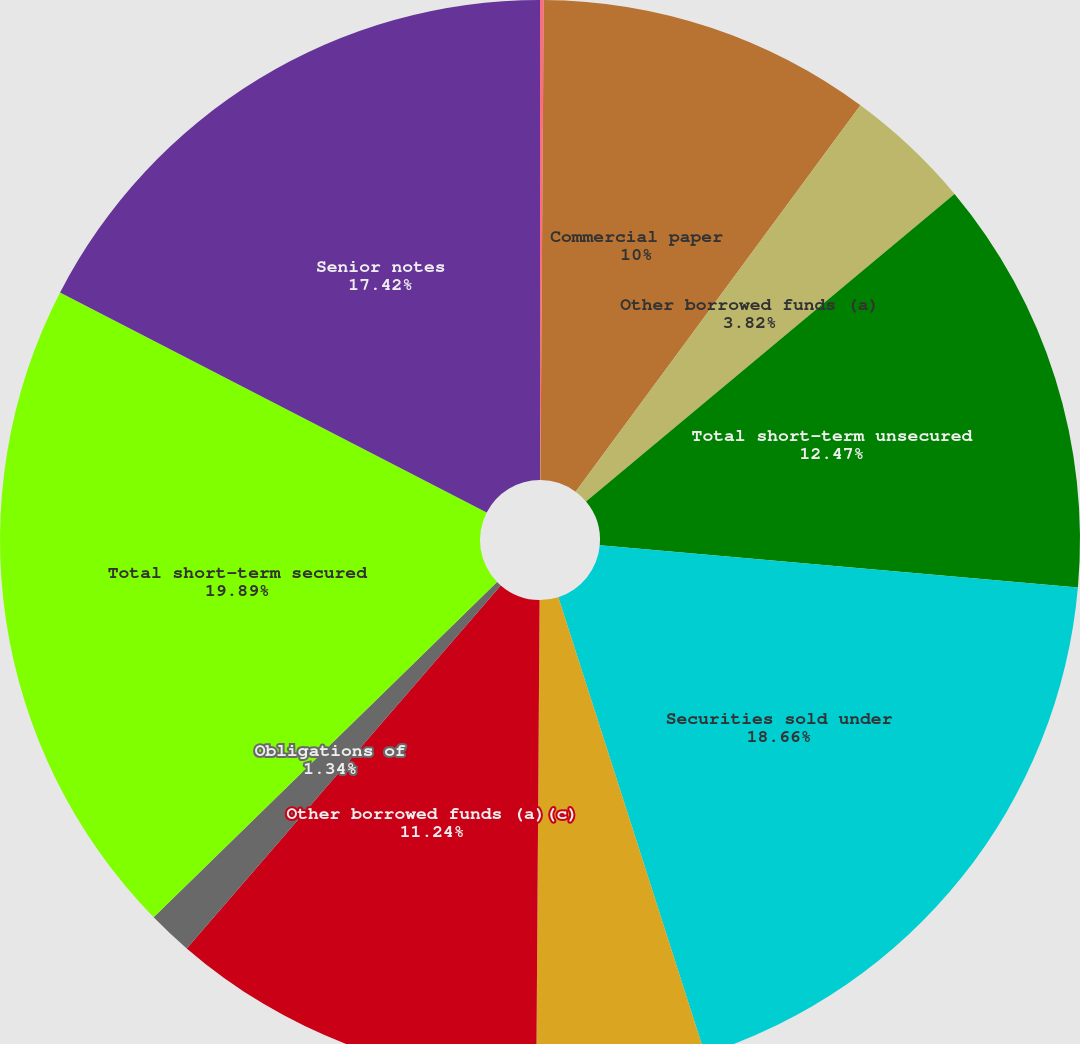Convert chart. <chart><loc_0><loc_0><loc_500><loc_500><pie_chart><fcel>(in millions)<fcel>Commercial paper<fcel>Other borrowed funds (a)<fcel>Total short-term unsecured<fcel>Securities sold under<fcel>Securities loaned (a)(b)<fcel>Other borrowed funds (a)(c)<fcel>Obligations of<fcel>Total short-term secured<fcel>Senior notes<nl><fcel>0.11%<fcel>10.0%<fcel>3.82%<fcel>12.47%<fcel>18.66%<fcel>5.05%<fcel>11.24%<fcel>1.34%<fcel>19.89%<fcel>17.42%<nl></chart> 